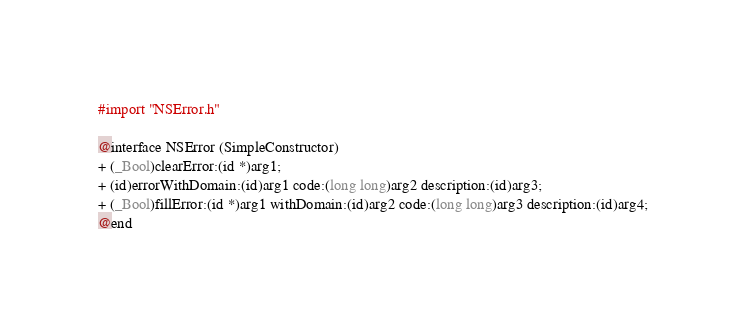Convert code to text. <code><loc_0><loc_0><loc_500><loc_500><_C_>#import "NSError.h"

@interface NSError (SimpleConstructor)
+ (_Bool)clearError:(id *)arg1;
+ (id)errorWithDomain:(id)arg1 code:(long long)arg2 description:(id)arg3;
+ (_Bool)fillError:(id *)arg1 withDomain:(id)arg2 code:(long long)arg3 description:(id)arg4;
@end

</code> 